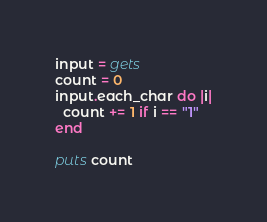<code> <loc_0><loc_0><loc_500><loc_500><_Ruby_>input = gets
count = 0
input.each_char do |i|
  count += 1 if i == "1"
end

puts count</code> 